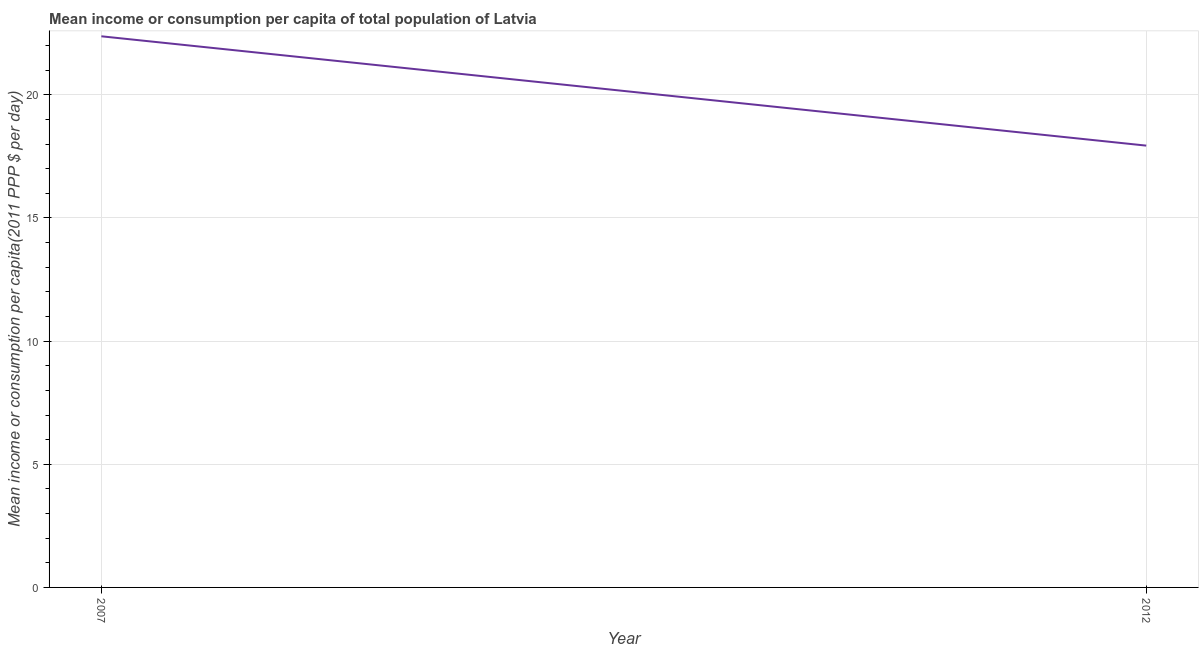What is the mean income or consumption in 2012?
Keep it short and to the point. 17.94. Across all years, what is the maximum mean income or consumption?
Make the answer very short. 22.38. Across all years, what is the minimum mean income or consumption?
Your answer should be compact. 17.94. In which year was the mean income or consumption maximum?
Make the answer very short. 2007. In which year was the mean income or consumption minimum?
Ensure brevity in your answer.  2012. What is the sum of the mean income or consumption?
Your answer should be compact. 40.31. What is the difference between the mean income or consumption in 2007 and 2012?
Offer a terse response. 4.44. What is the average mean income or consumption per year?
Your answer should be very brief. 20.16. What is the median mean income or consumption?
Give a very brief answer. 20.16. In how many years, is the mean income or consumption greater than 8 $?
Your response must be concise. 2. What is the ratio of the mean income or consumption in 2007 to that in 2012?
Your response must be concise. 1.25. In how many years, is the mean income or consumption greater than the average mean income or consumption taken over all years?
Provide a succinct answer. 1. How many lines are there?
Provide a succinct answer. 1. How many years are there in the graph?
Your response must be concise. 2. What is the title of the graph?
Give a very brief answer. Mean income or consumption per capita of total population of Latvia. What is the label or title of the X-axis?
Provide a succinct answer. Year. What is the label or title of the Y-axis?
Offer a terse response. Mean income or consumption per capita(2011 PPP $ per day). What is the Mean income or consumption per capita(2011 PPP $ per day) of 2007?
Your answer should be compact. 22.38. What is the Mean income or consumption per capita(2011 PPP $ per day) in 2012?
Make the answer very short. 17.94. What is the difference between the Mean income or consumption per capita(2011 PPP $ per day) in 2007 and 2012?
Keep it short and to the point. 4.44. What is the ratio of the Mean income or consumption per capita(2011 PPP $ per day) in 2007 to that in 2012?
Your response must be concise. 1.25. 